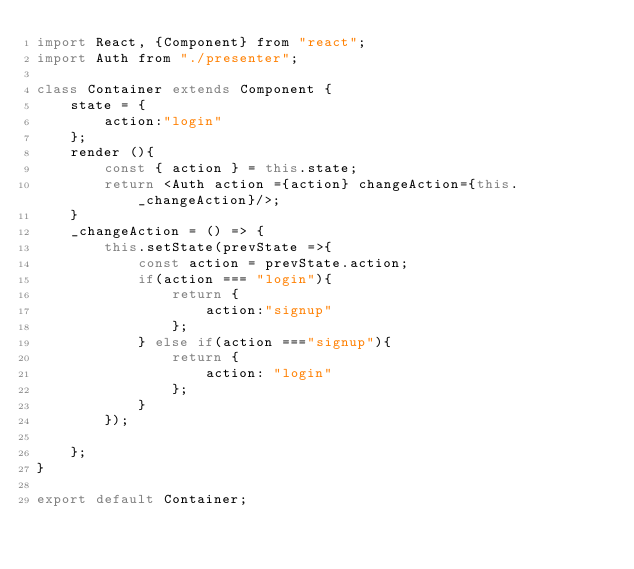Convert code to text. <code><loc_0><loc_0><loc_500><loc_500><_JavaScript_>import React, {Component} from "react";
import Auth from "./presenter";

class Container extends Component {
    state = {
        action:"login"
    };
    render (){
        const { action } = this.state;
        return <Auth action ={action} changeAction={this._changeAction}/>;
    }
    _changeAction = () => {
        this.setState(prevState =>{
            const action = prevState.action;
            if(action === "login"){
                return {
                    action:"signup"
                };
            } else if(action ==="signup"){
                return {
                    action: "login"
                };
            }
        });
        
    };
}

export default Container;</code> 